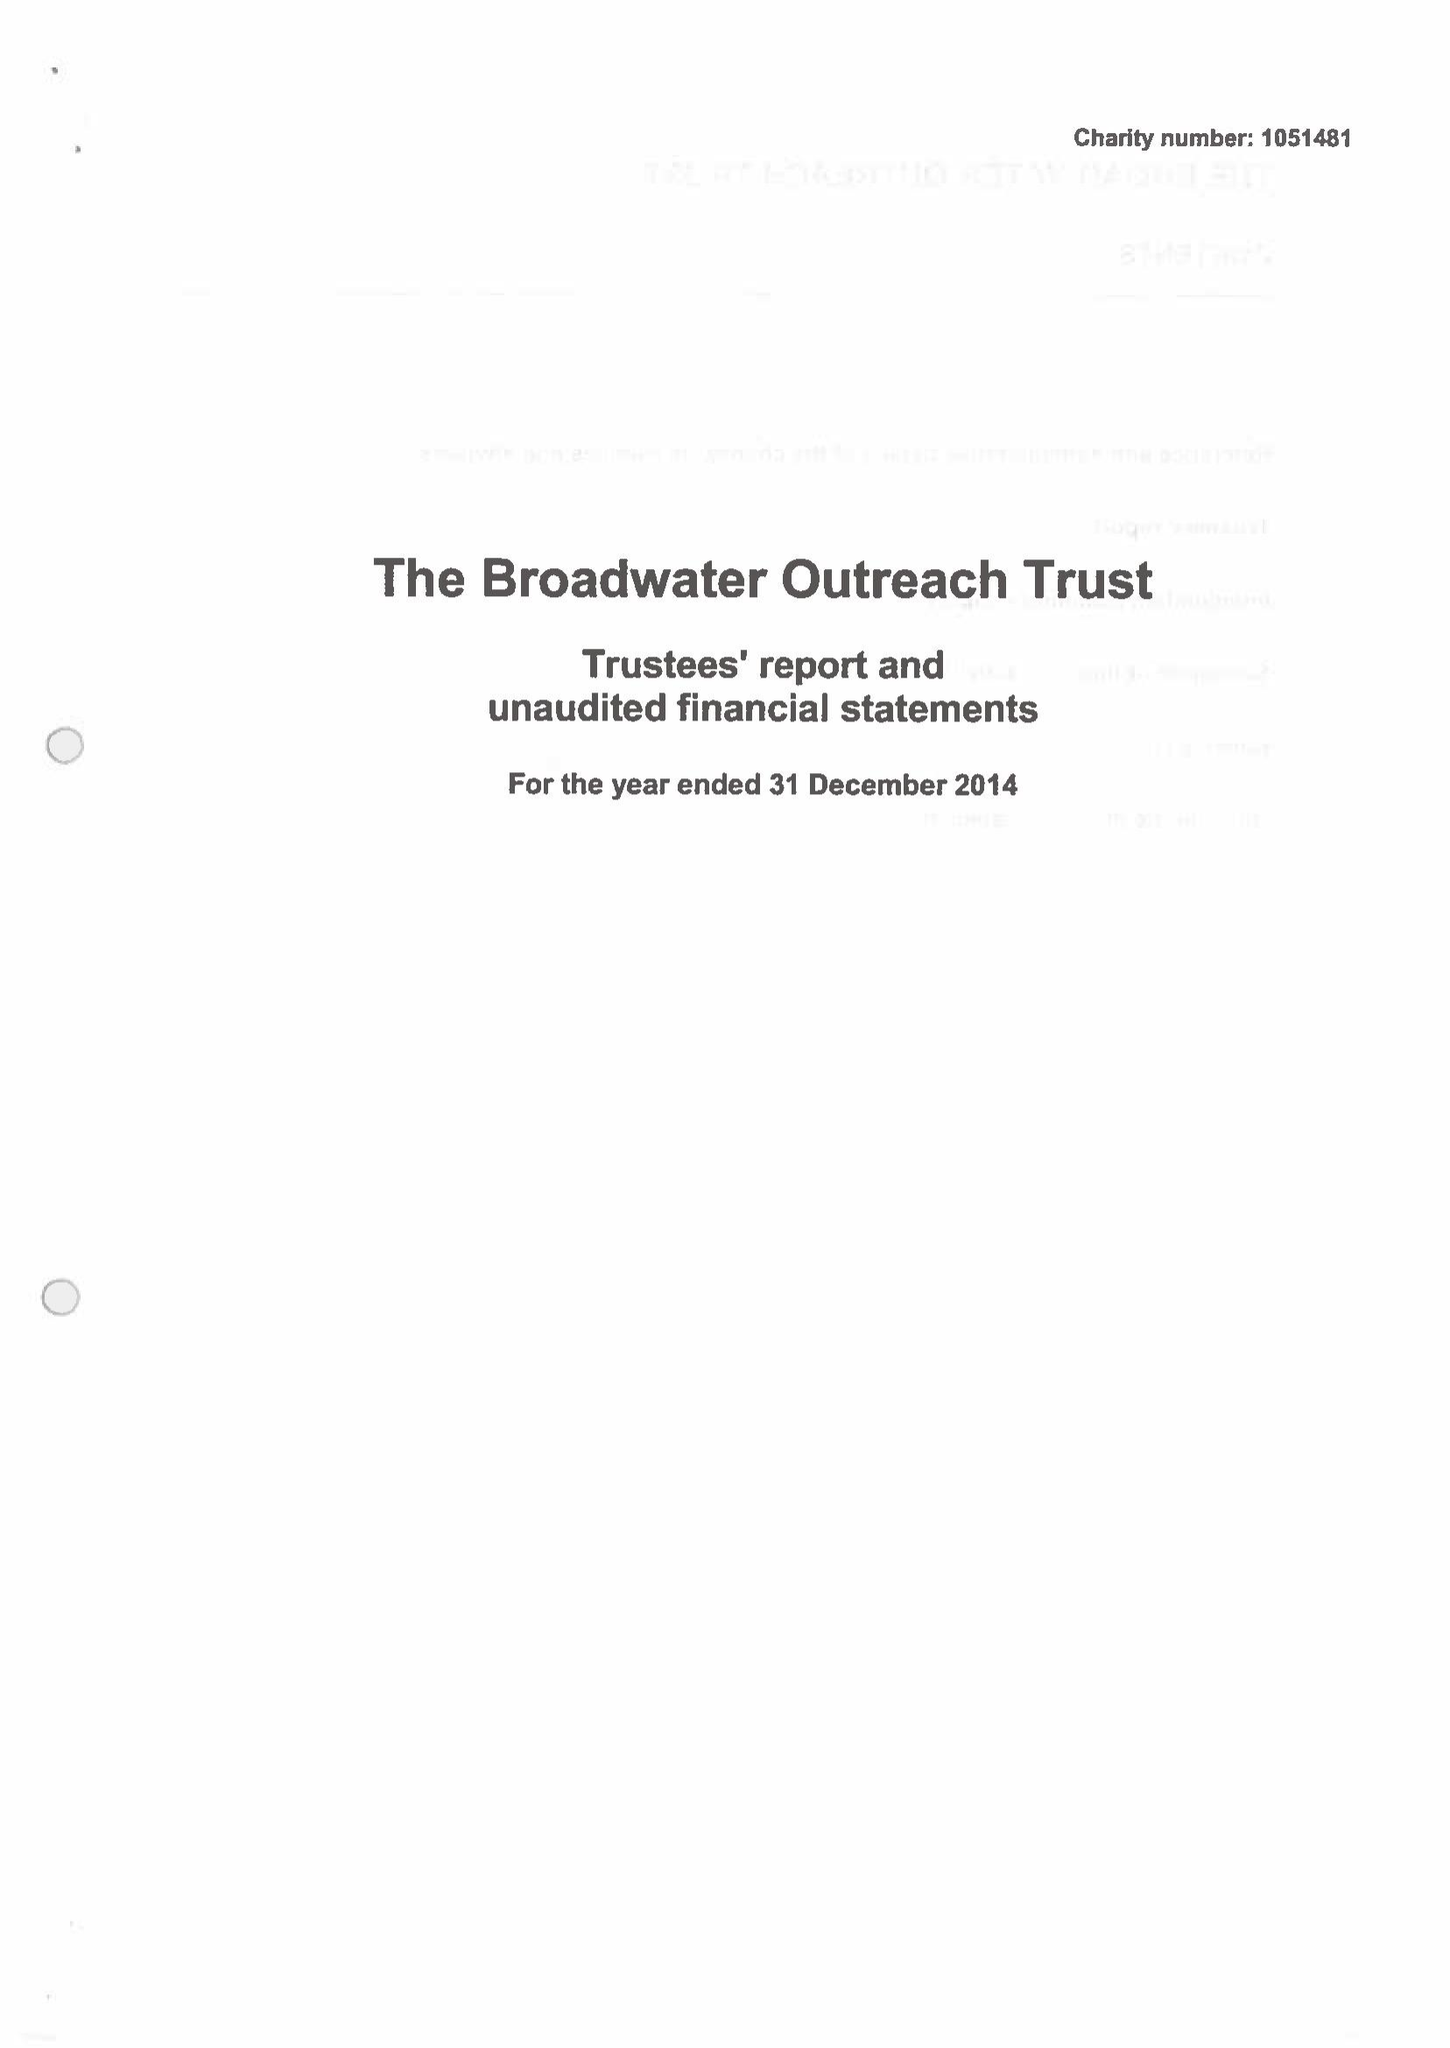What is the value for the report_date?
Answer the question using a single word or phrase. 2014-12-31 